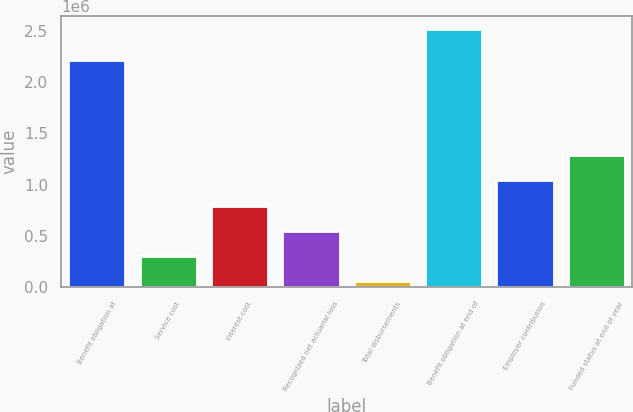Convert chart to OTSL. <chart><loc_0><loc_0><loc_500><loc_500><bar_chart><fcel>Benefit obligation at<fcel>Service cost<fcel>Interest cost<fcel>Recognized net actuarial loss<fcel>Total disbursements<fcel>Benefit obligation at end of<fcel>Employer contribution<fcel>Funded status at end of year<nl><fcel>2.2123e+06<fcel>305868<fcel>797156<fcel>551512<fcel>60225<fcel>2.51666e+06<fcel>1.0428e+06<fcel>1.28844e+06<nl></chart> 